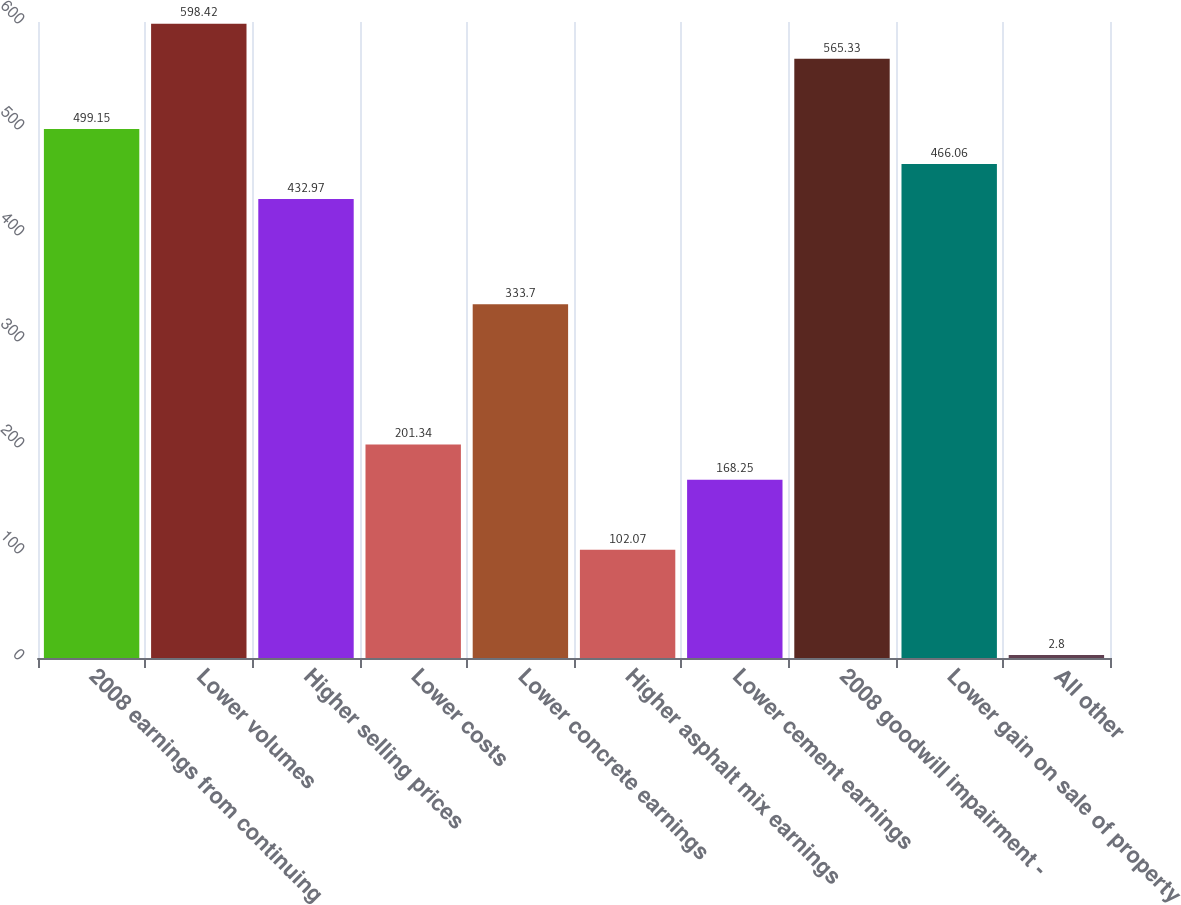Convert chart. <chart><loc_0><loc_0><loc_500><loc_500><bar_chart><fcel>2008 earnings from continuing<fcel>Lower volumes<fcel>Higher selling prices<fcel>Lower costs<fcel>Lower concrete earnings<fcel>Higher asphalt mix earnings<fcel>Lower cement earnings<fcel>2008 goodwill impairment -<fcel>Lower gain on sale of property<fcel>All other<nl><fcel>499.15<fcel>598.42<fcel>432.97<fcel>201.34<fcel>333.7<fcel>102.07<fcel>168.25<fcel>565.33<fcel>466.06<fcel>2.8<nl></chart> 